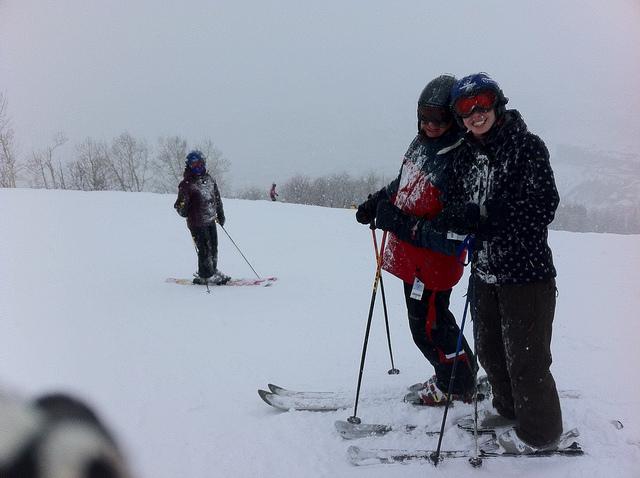What shape is on the man's hat?
Quick response, please. Round. How many poles?
Answer briefly. 6. How many people are there?
Give a very brief answer. 4. Do all the skiers have three digit numbers on their backs?
Write a very short answer. No. Is it cold?
Answer briefly. Yes. Where are they standing?
Answer briefly. In snow. What keep these people from being cold?
Be succinct. Jackets. What number of skis are in the snow?
Be succinct. 6. How is the weather for skiing?
Write a very short answer. Good. How many skis are shown?
Be succinct. 6. How are the visibility conditions?
Keep it brief. Poor. 